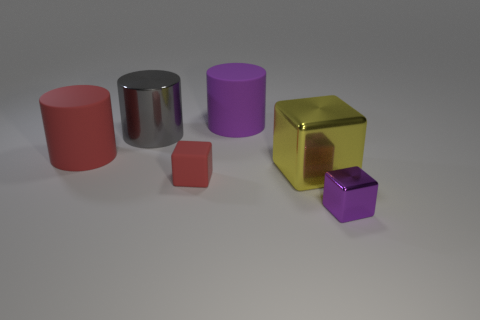Subtract all metallic cubes. How many cubes are left? 1 Subtract all gray cylinders. How many cylinders are left? 2 Add 4 big yellow shiny blocks. How many objects exist? 10 Subtract 3 cylinders. How many cylinders are left? 0 Subtract 0 green cylinders. How many objects are left? 6 Subtract all blue cubes. Subtract all purple spheres. How many cubes are left? 3 Subtract all gray cylinders. How many brown cubes are left? 0 Subtract all small red matte blocks. Subtract all large red rubber things. How many objects are left? 4 Add 4 yellow metal blocks. How many yellow metal blocks are left? 5 Add 1 cubes. How many cubes exist? 4 